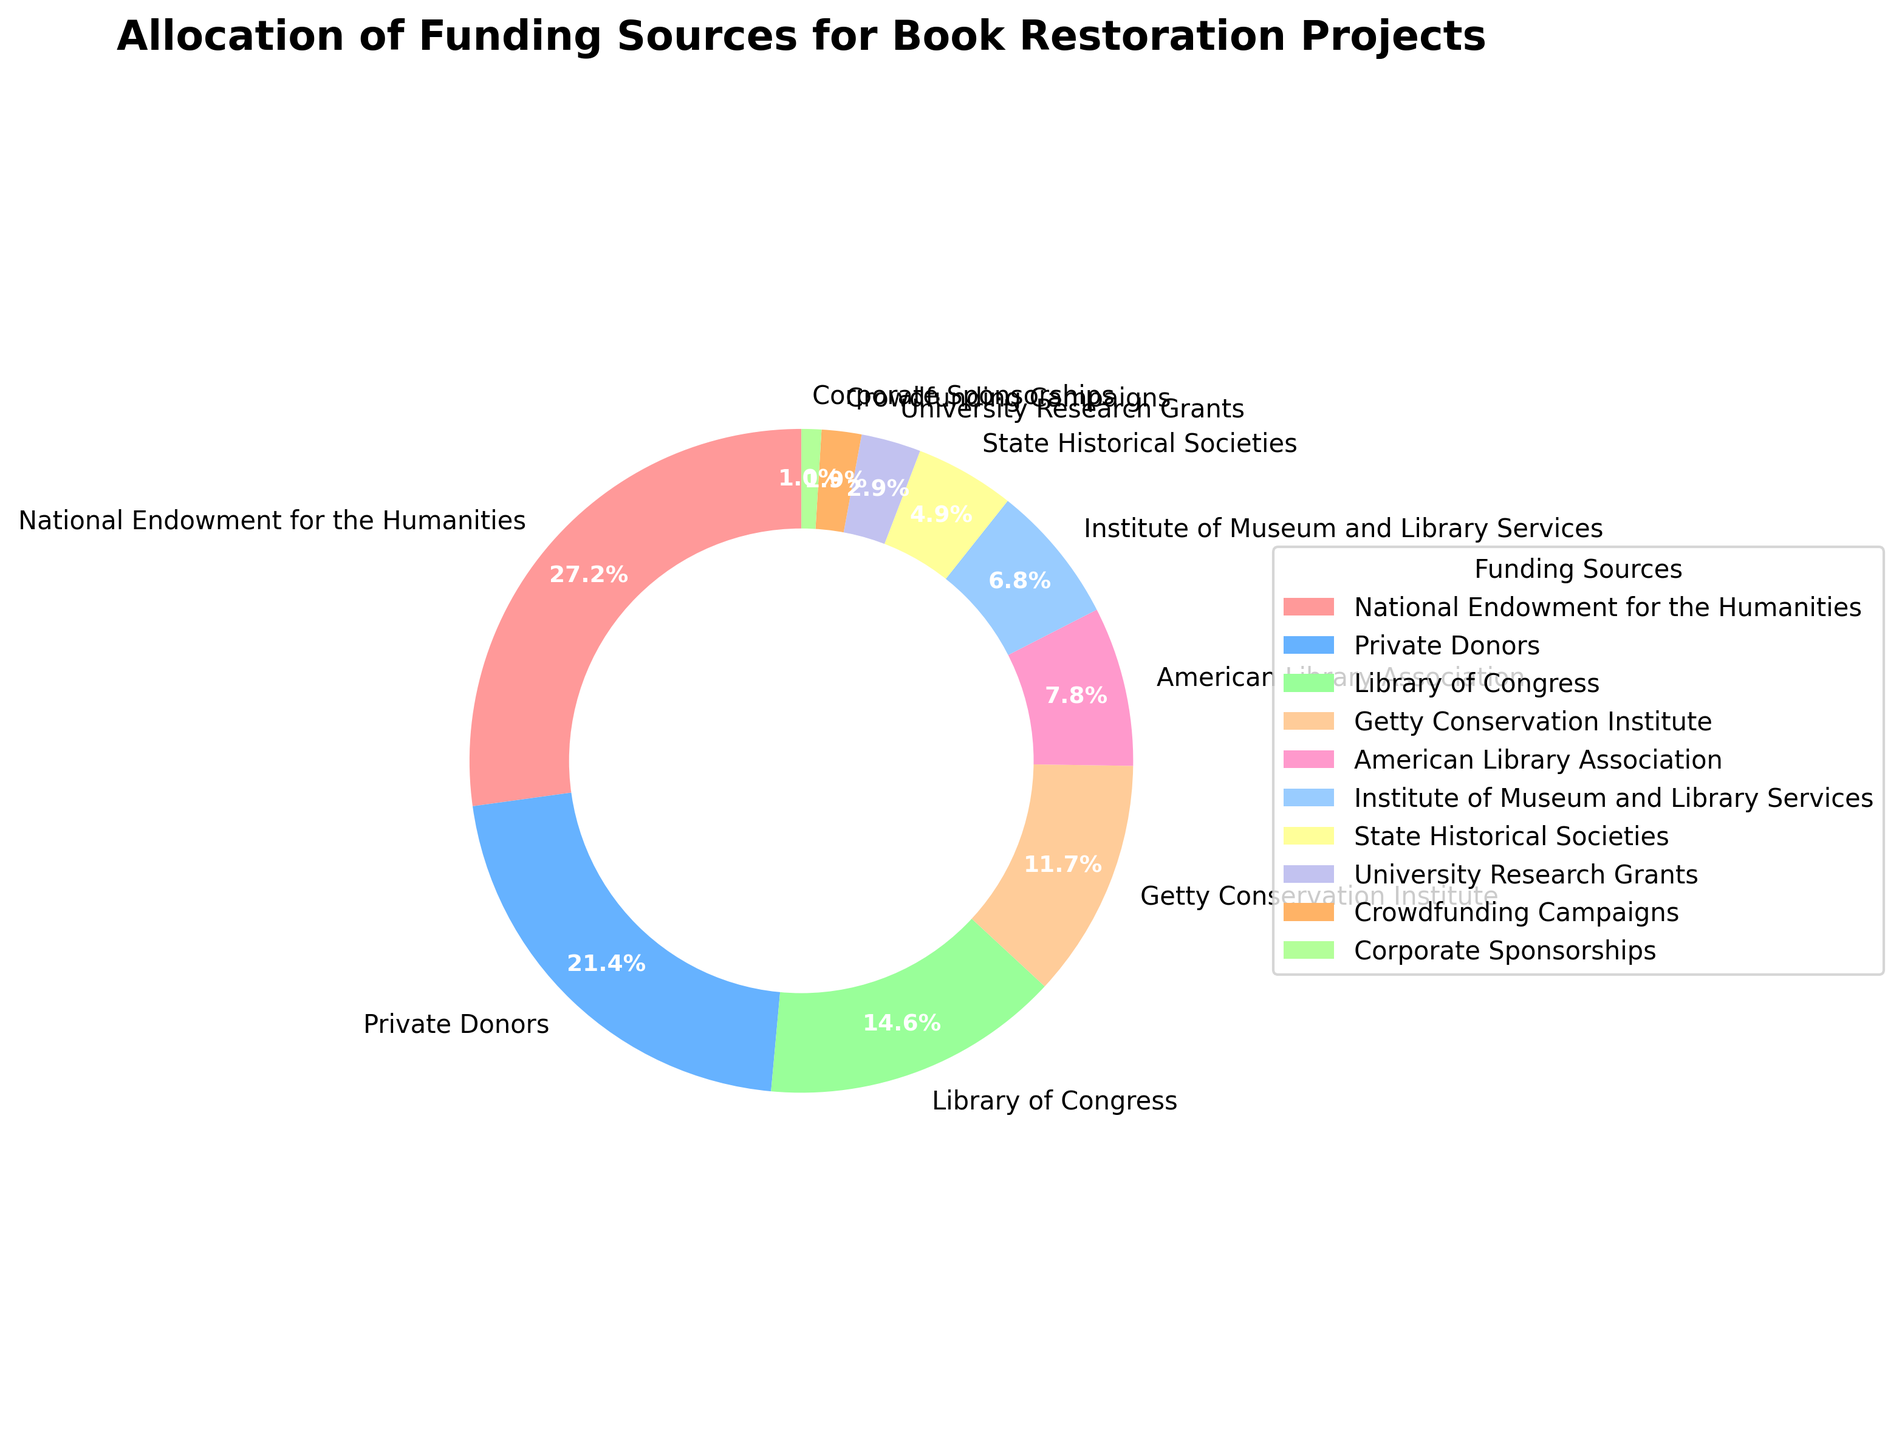What percentage of funding comes from the top three sources combined? The top three sources are National Endowment for the Humanities (28%), Private Donors (22%), and Library of Congress (15%). Summing them up: 28 + 22 + 15 = 65%.
Answer: 65% Which funding source provides more support, the American Library Association or the Institute of Museum and Library Services? The percentage for American Library Association is 8%, and for Institute of Museum and Library Services, it is 7%. Therefore, American Library Association provides more support.
Answer: American Library Association How many funding sources contribute less than 10% each? The sources contributing less than 10% are American Library Association (8%), Institute of Museum and Library Services (7%), State Historical Societies (5%), University Research Grants (3%), Crowdfunding Campaigns (2%), and Corporate Sponsorships (1%). There are 6 such sources.
Answer: 6 What is the visual characteristic of the funding source slice that has the smallest allocation? The slice for Corporate Sponsorships has the smallest allocation and is visually depicted with the smallest segment in width.
Answer: The smallest segment Is the combined contribution of the three least contributing sources greater than that of Getty Conservation Institute? The three least contributing sources are University Research Grants (3%), Crowdfunding Campaigns (2%), and Corporate Sponsorships (1%). Their combined contribution is 3 + 2 + 1 = 6%, which is less than Getty Conservation Institute's 12%.
Answer: No By how much does the contribution of Private Donors exceed that of the Library of Congress? The contribution of Private Donors is 22% and that of the Library of Congress is 15%. The difference is 22 - 15 = 7%.
Answer: 7% Which two funding sources have percentages adding up closest to the contribution of National Endowment for the Humanities? Institute of Museum and Library Services (7%) + State Historical Societies (5%) = 12%, American Library Association (8%) + Getty Conservation Institute (12%) = 20%, Private Donors (22%) + Crowdfunding Campaigns (2%) = 24%, etc. Thus, Institute of Museum and Library Services (7%) and Library of Congress (15%) add up closest to 28% with a total of 22%.
Answer: Institute of Museum and Library Services and Library of Congress 